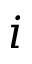Convert formula to latex. <formula><loc_0><loc_0><loc_500><loc_500>i</formula> 